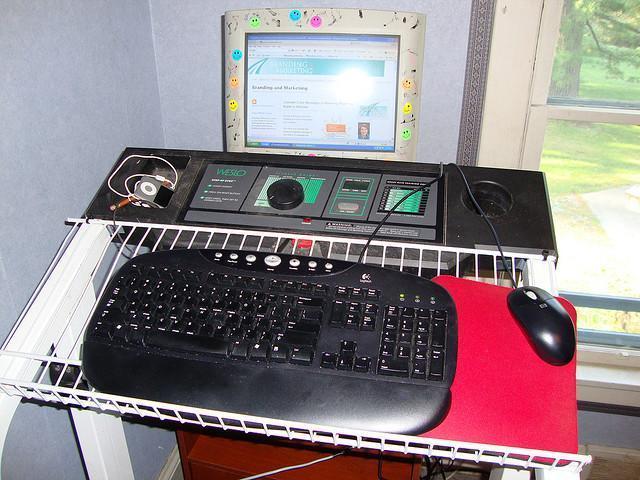How many screens are in the image?
Give a very brief answer. 1. How many boats are in the water?
Give a very brief answer. 0. 